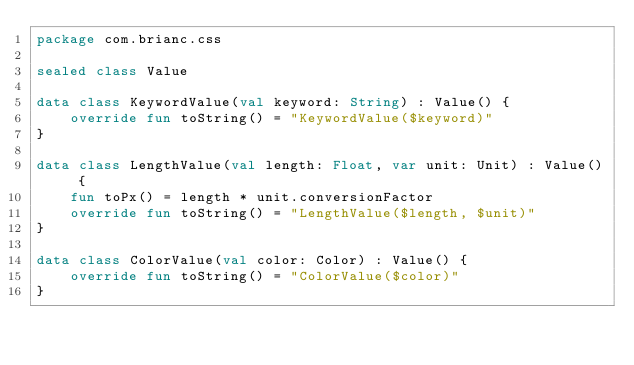<code> <loc_0><loc_0><loc_500><loc_500><_Kotlin_>package com.brianc.css

sealed class Value

data class KeywordValue(val keyword: String) : Value() {
    override fun toString() = "KeywordValue($keyword)"
}

data class LengthValue(val length: Float, var unit: Unit) : Value() {
    fun toPx() = length * unit.conversionFactor
    override fun toString() = "LengthValue($length, $unit)"
}

data class ColorValue(val color: Color) : Value() {
    override fun toString() = "ColorValue($color)"
}
</code> 